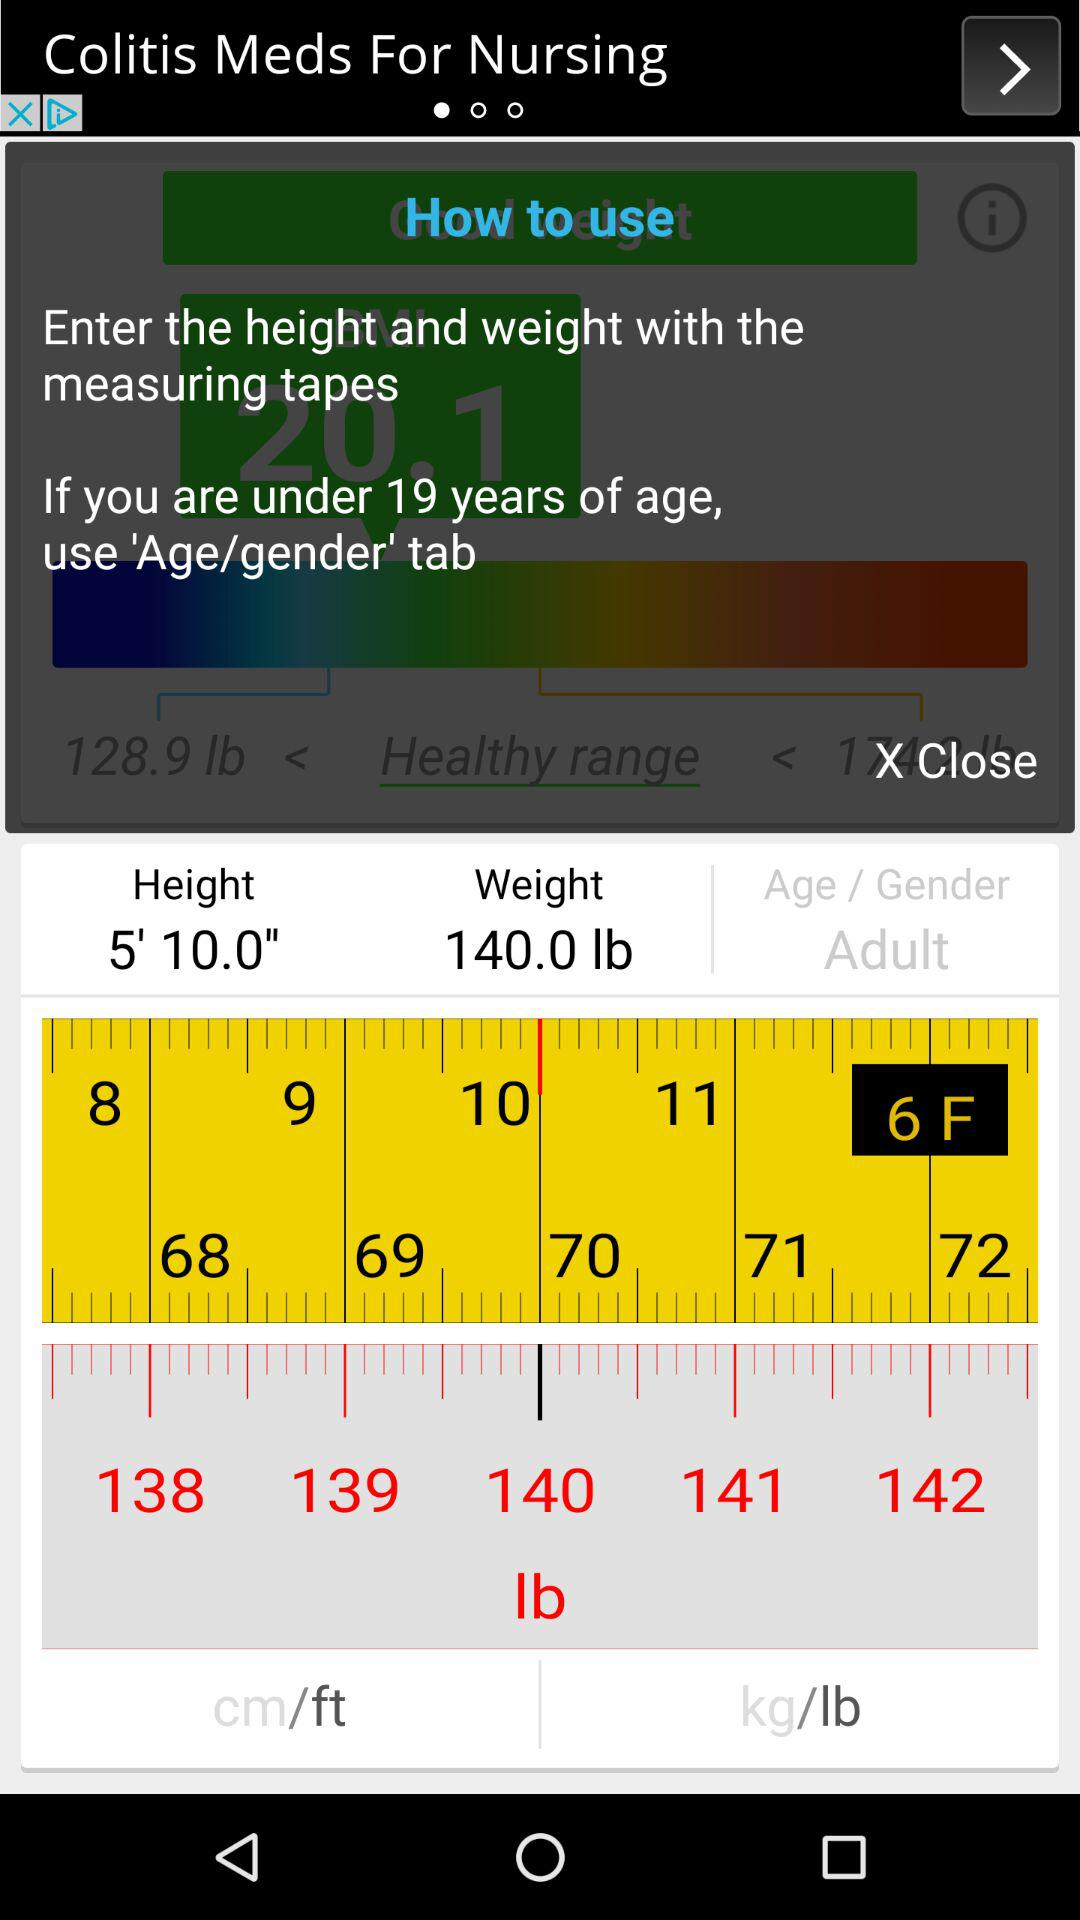What is the age criteria for using the "Age/gender" tab? The age criteria is under 19 years. 